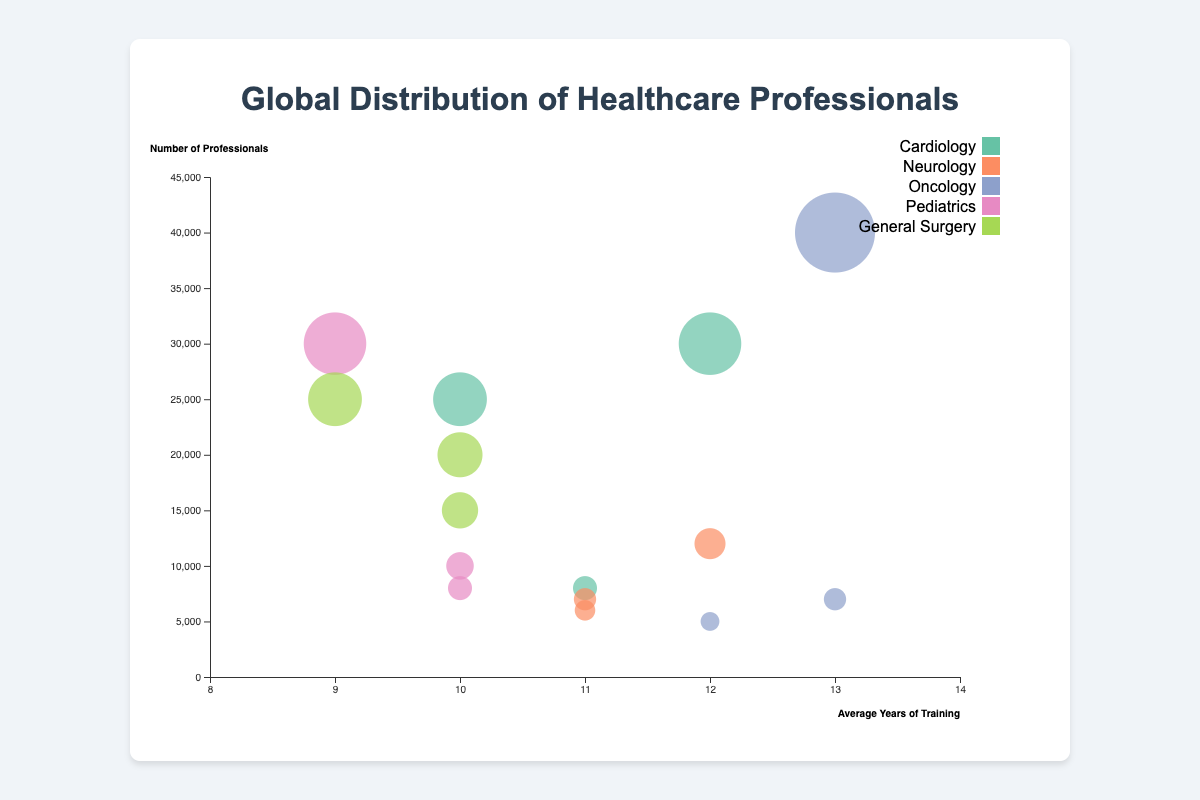What is the title of the chart? The title is located at the top of the chart and provides a summary of what the chart is about. It reads "Global Distribution of Healthcare Professionals." From this, we know the chart involves data about healthcare professionals globally.
Answer: Global Distribution of Healthcare Professionals How many specialties are represented in the chart? The legend in the chart lists each specialization using distinct colors. By counting the entries in the legend, we can determine that there are five specializations: Cardiology, Neurology, Oncology, Pediatrics, and General Surgery.
Answer: Five Which country has the highest number of professionals in Oncology? By looking at the size of the bubbles and the tooltip information on hovering over them, we can identify the country with the largest bubble for Oncology. This bubble is found to be the largest in the dataset and corresponds to China.
Answer: China Which specialization has the highest average years of training? To find this, we need to look at the x-axis values. Oncology has bubbles furthest to the right, indicating it has the highest average years of training, which peaks at 13 years.
Answer: Oncology What is the average number of professionals for Neurology in the chart? Neurology professionals are represented by three bubbles. We add up their professionals (7000 + 6000 + 12000) and then divide by the number of bubbles (3). The calculation is: (7000 + 6000 + 12000) / 3 = 25000 / 3 ≈ 8333.
Answer: Approximately 8333 Comparing Brazil and India, which country has more professionals in Pediatrics? We look for bubbles corresponding to Pediatrics and compare their sizes for the two countries. Brazil’s bubble represents 30000 professionals, whereas India only has data for General Surgery. Hence, Brazil has more professionals in Pediatrics.
Answer: Brazil Which specialization has the most diverse range of training years? We need to identify the specialization with bubbles spread across the widest range of x-axis values. Cardiology’s bubbles range from 10 to 12 years of training, but Oncology ranges from 12 to 13 years, indicating it has a fairly diverse range, though not as much as some others. The widest overall range seems to be for General Surgery and Pediatrics, but Oncology stands notably diverse too.
Answer: General Surgery Which specialization-country pair has the largest bubble? The largest bubble will represent the maximum number of professionals. By hovering over the bubbles, we find that the Oncology specialization in China, with 40000 professionals, has the largest bubble.
Answer: Oncology in China Does any bubble overlap entirely another one for the specific x and y coordinates? By visually inspecting the chart for overlapping data points demarcated by circles, we notice that while some bubbles touch, none overlap entirely on both axes.
Answer: No 